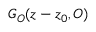<formula> <loc_0><loc_0><loc_500><loc_500>G _ { O } ( z - z _ { 0 } , O )</formula> 